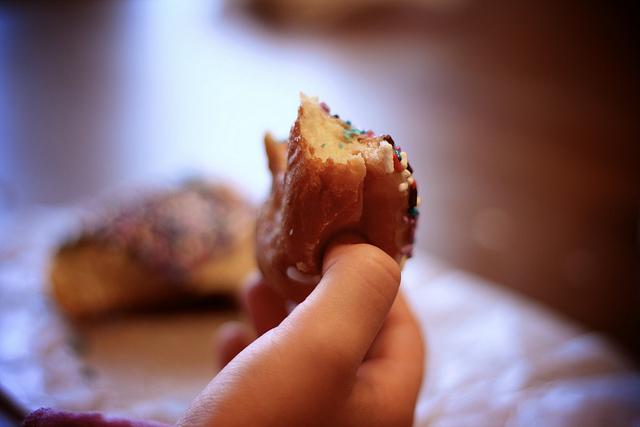Is this the hand of an elderly person?
Concise answer only. No. What pastry is shown?
Concise answer only. Donut. What finger is being shown in front?
Short answer required. Thumb. Are there sprinkles on the donut?
Answer briefly. Yes. 